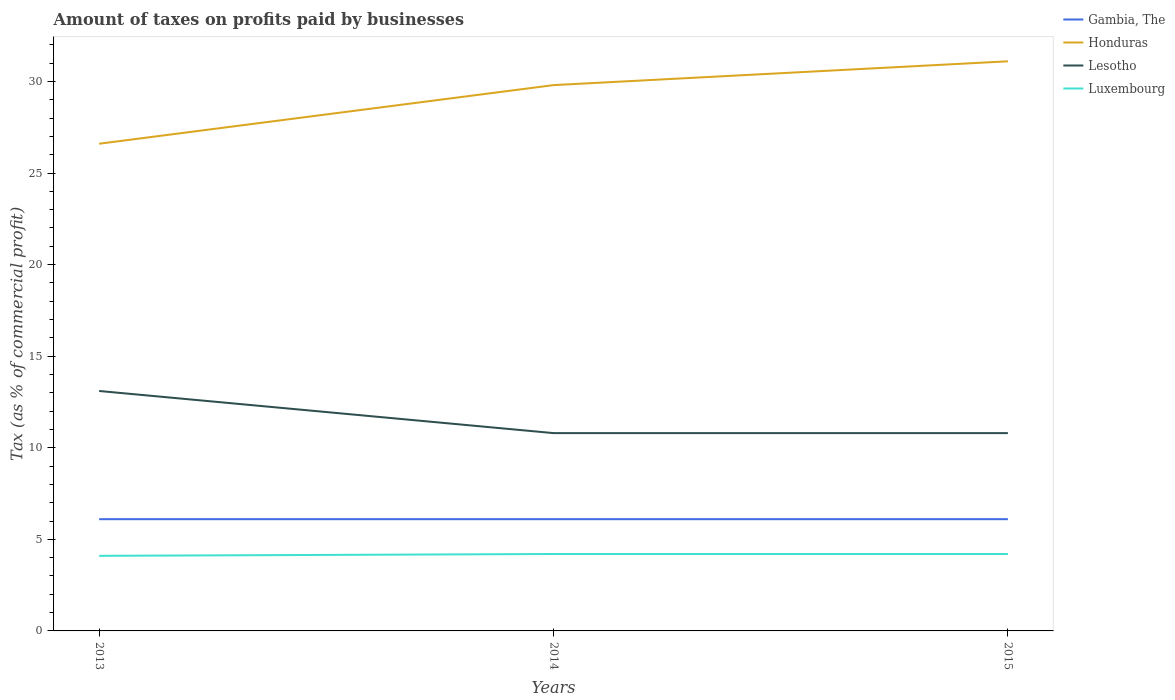How many different coloured lines are there?
Offer a terse response. 4. Does the line corresponding to Lesotho intersect with the line corresponding to Luxembourg?
Your response must be concise. No. Is the number of lines equal to the number of legend labels?
Keep it short and to the point. Yes. Across all years, what is the maximum percentage of taxes paid by businesses in Honduras?
Your answer should be very brief. 26.6. What is the total percentage of taxes paid by businesses in Honduras in the graph?
Ensure brevity in your answer.  -1.3. How many years are there in the graph?
Your answer should be compact. 3. What is the difference between two consecutive major ticks on the Y-axis?
Keep it short and to the point. 5. Does the graph contain any zero values?
Give a very brief answer. No. Does the graph contain grids?
Your response must be concise. No. How many legend labels are there?
Keep it short and to the point. 4. What is the title of the graph?
Provide a succinct answer. Amount of taxes on profits paid by businesses. What is the label or title of the Y-axis?
Your answer should be compact. Tax (as % of commercial profit). What is the Tax (as % of commercial profit) of Gambia, The in 2013?
Offer a terse response. 6.1. What is the Tax (as % of commercial profit) of Honduras in 2013?
Provide a succinct answer. 26.6. What is the Tax (as % of commercial profit) of Lesotho in 2013?
Provide a succinct answer. 13.1. What is the Tax (as % of commercial profit) in Gambia, The in 2014?
Offer a very short reply. 6.1. What is the Tax (as % of commercial profit) of Honduras in 2014?
Offer a very short reply. 29.8. What is the Tax (as % of commercial profit) in Luxembourg in 2014?
Provide a short and direct response. 4.2. What is the Tax (as % of commercial profit) of Gambia, The in 2015?
Provide a short and direct response. 6.1. What is the Tax (as % of commercial profit) of Honduras in 2015?
Your answer should be compact. 31.1. What is the Tax (as % of commercial profit) of Luxembourg in 2015?
Your answer should be very brief. 4.2. Across all years, what is the maximum Tax (as % of commercial profit) of Gambia, The?
Ensure brevity in your answer.  6.1. Across all years, what is the maximum Tax (as % of commercial profit) in Honduras?
Offer a terse response. 31.1. Across all years, what is the maximum Tax (as % of commercial profit) of Lesotho?
Ensure brevity in your answer.  13.1. Across all years, what is the maximum Tax (as % of commercial profit) in Luxembourg?
Give a very brief answer. 4.2. Across all years, what is the minimum Tax (as % of commercial profit) of Gambia, The?
Ensure brevity in your answer.  6.1. Across all years, what is the minimum Tax (as % of commercial profit) of Honduras?
Your response must be concise. 26.6. Across all years, what is the minimum Tax (as % of commercial profit) in Luxembourg?
Your answer should be compact. 4.1. What is the total Tax (as % of commercial profit) in Gambia, The in the graph?
Your answer should be very brief. 18.3. What is the total Tax (as % of commercial profit) of Honduras in the graph?
Provide a short and direct response. 87.5. What is the total Tax (as % of commercial profit) in Lesotho in the graph?
Ensure brevity in your answer.  34.7. What is the total Tax (as % of commercial profit) of Luxembourg in the graph?
Give a very brief answer. 12.5. What is the difference between the Tax (as % of commercial profit) in Gambia, The in 2013 and that in 2014?
Offer a very short reply. 0. What is the difference between the Tax (as % of commercial profit) of Honduras in 2013 and that in 2014?
Offer a terse response. -3.2. What is the difference between the Tax (as % of commercial profit) of Gambia, The in 2013 and that in 2015?
Your response must be concise. 0. What is the difference between the Tax (as % of commercial profit) of Honduras in 2013 and that in 2015?
Your response must be concise. -4.5. What is the difference between the Tax (as % of commercial profit) in Lesotho in 2013 and that in 2015?
Make the answer very short. 2.3. What is the difference between the Tax (as % of commercial profit) of Gambia, The in 2014 and that in 2015?
Keep it short and to the point. 0. What is the difference between the Tax (as % of commercial profit) of Lesotho in 2014 and that in 2015?
Your answer should be very brief. 0. What is the difference between the Tax (as % of commercial profit) of Gambia, The in 2013 and the Tax (as % of commercial profit) of Honduras in 2014?
Give a very brief answer. -23.7. What is the difference between the Tax (as % of commercial profit) of Gambia, The in 2013 and the Tax (as % of commercial profit) of Luxembourg in 2014?
Your answer should be compact. 1.9. What is the difference between the Tax (as % of commercial profit) of Honduras in 2013 and the Tax (as % of commercial profit) of Lesotho in 2014?
Give a very brief answer. 15.8. What is the difference between the Tax (as % of commercial profit) of Honduras in 2013 and the Tax (as % of commercial profit) of Luxembourg in 2014?
Make the answer very short. 22.4. What is the difference between the Tax (as % of commercial profit) of Gambia, The in 2013 and the Tax (as % of commercial profit) of Honduras in 2015?
Your answer should be very brief. -25. What is the difference between the Tax (as % of commercial profit) of Gambia, The in 2013 and the Tax (as % of commercial profit) of Luxembourg in 2015?
Your answer should be very brief. 1.9. What is the difference between the Tax (as % of commercial profit) in Honduras in 2013 and the Tax (as % of commercial profit) in Lesotho in 2015?
Make the answer very short. 15.8. What is the difference between the Tax (as % of commercial profit) of Honduras in 2013 and the Tax (as % of commercial profit) of Luxembourg in 2015?
Provide a succinct answer. 22.4. What is the difference between the Tax (as % of commercial profit) in Gambia, The in 2014 and the Tax (as % of commercial profit) in Lesotho in 2015?
Make the answer very short. -4.7. What is the difference between the Tax (as % of commercial profit) in Gambia, The in 2014 and the Tax (as % of commercial profit) in Luxembourg in 2015?
Provide a succinct answer. 1.9. What is the difference between the Tax (as % of commercial profit) in Honduras in 2014 and the Tax (as % of commercial profit) in Lesotho in 2015?
Make the answer very short. 19. What is the difference between the Tax (as % of commercial profit) in Honduras in 2014 and the Tax (as % of commercial profit) in Luxembourg in 2015?
Offer a terse response. 25.6. What is the average Tax (as % of commercial profit) of Honduras per year?
Your response must be concise. 29.17. What is the average Tax (as % of commercial profit) in Lesotho per year?
Provide a short and direct response. 11.57. What is the average Tax (as % of commercial profit) of Luxembourg per year?
Keep it short and to the point. 4.17. In the year 2013, what is the difference between the Tax (as % of commercial profit) in Gambia, The and Tax (as % of commercial profit) in Honduras?
Offer a terse response. -20.5. In the year 2013, what is the difference between the Tax (as % of commercial profit) in Gambia, The and Tax (as % of commercial profit) in Lesotho?
Your answer should be very brief. -7. In the year 2013, what is the difference between the Tax (as % of commercial profit) in Gambia, The and Tax (as % of commercial profit) in Luxembourg?
Provide a short and direct response. 2. In the year 2013, what is the difference between the Tax (as % of commercial profit) of Lesotho and Tax (as % of commercial profit) of Luxembourg?
Offer a very short reply. 9. In the year 2014, what is the difference between the Tax (as % of commercial profit) of Gambia, The and Tax (as % of commercial profit) of Honduras?
Offer a very short reply. -23.7. In the year 2014, what is the difference between the Tax (as % of commercial profit) of Honduras and Tax (as % of commercial profit) of Lesotho?
Your response must be concise. 19. In the year 2014, what is the difference between the Tax (as % of commercial profit) in Honduras and Tax (as % of commercial profit) in Luxembourg?
Your answer should be compact. 25.6. In the year 2015, what is the difference between the Tax (as % of commercial profit) in Gambia, The and Tax (as % of commercial profit) in Honduras?
Keep it short and to the point. -25. In the year 2015, what is the difference between the Tax (as % of commercial profit) of Gambia, The and Tax (as % of commercial profit) of Lesotho?
Provide a succinct answer. -4.7. In the year 2015, what is the difference between the Tax (as % of commercial profit) of Gambia, The and Tax (as % of commercial profit) of Luxembourg?
Ensure brevity in your answer.  1.9. In the year 2015, what is the difference between the Tax (as % of commercial profit) of Honduras and Tax (as % of commercial profit) of Lesotho?
Your response must be concise. 20.3. In the year 2015, what is the difference between the Tax (as % of commercial profit) of Honduras and Tax (as % of commercial profit) of Luxembourg?
Provide a succinct answer. 26.9. In the year 2015, what is the difference between the Tax (as % of commercial profit) of Lesotho and Tax (as % of commercial profit) of Luxembourg?
Give a very brief answer. 6.6. What is the ratio of the Tax (as % of commercial profit) in Gambia, The in 2013 to that in 2014?
Your answer should be very brief. 1. What is the ratio of the Tax (as % of commercial profit) in Honduras in 2013 to that in 2014?
Make the answer very short. 0.89. What is the ratio of the Tax (as % of commercial profit) of Lesotho in 2013 to that in 2014?
Your answer should be compact. 1.21. What is the ratio of the Tax (as % of commercial profit) in Luxembourg in 2013 to that in 2014?
Offer a very short reply. 0.98. What is the ratio of the Tax (as % of commercial profit) of Honduras in 2013 to that in 2015?
Provide a short and direct response. 0.86. What is the ratio of the Tax (as % of commercial profit) of Lesotho in 2013 to that in 2015?
Provide a short and direct response. 1.21. What is the ratio of the Tax (as % of commercial profit) in Luxembourg in 2013 to that in 2015?
Your answer should be very brief. 0.98. What is the ratio of the Tax (as % of commercial profit) in Honduras in 2014 to that in 2015?
Your response must be concise. 0.96. What is the ratio of the Tax (as % of commercial profit) in Lesotho in 2014 to that in 2015?
Your response must be concise. 1. What is the difference between the highest and the second highest Tax (as % of commercial profit) in Honduras?
Offer a terse response. 1.3. What is the difference between the highest and the lowest Tax (as % of commercial profit) of Gambia, The?
Provide a succinct answer. 0. 